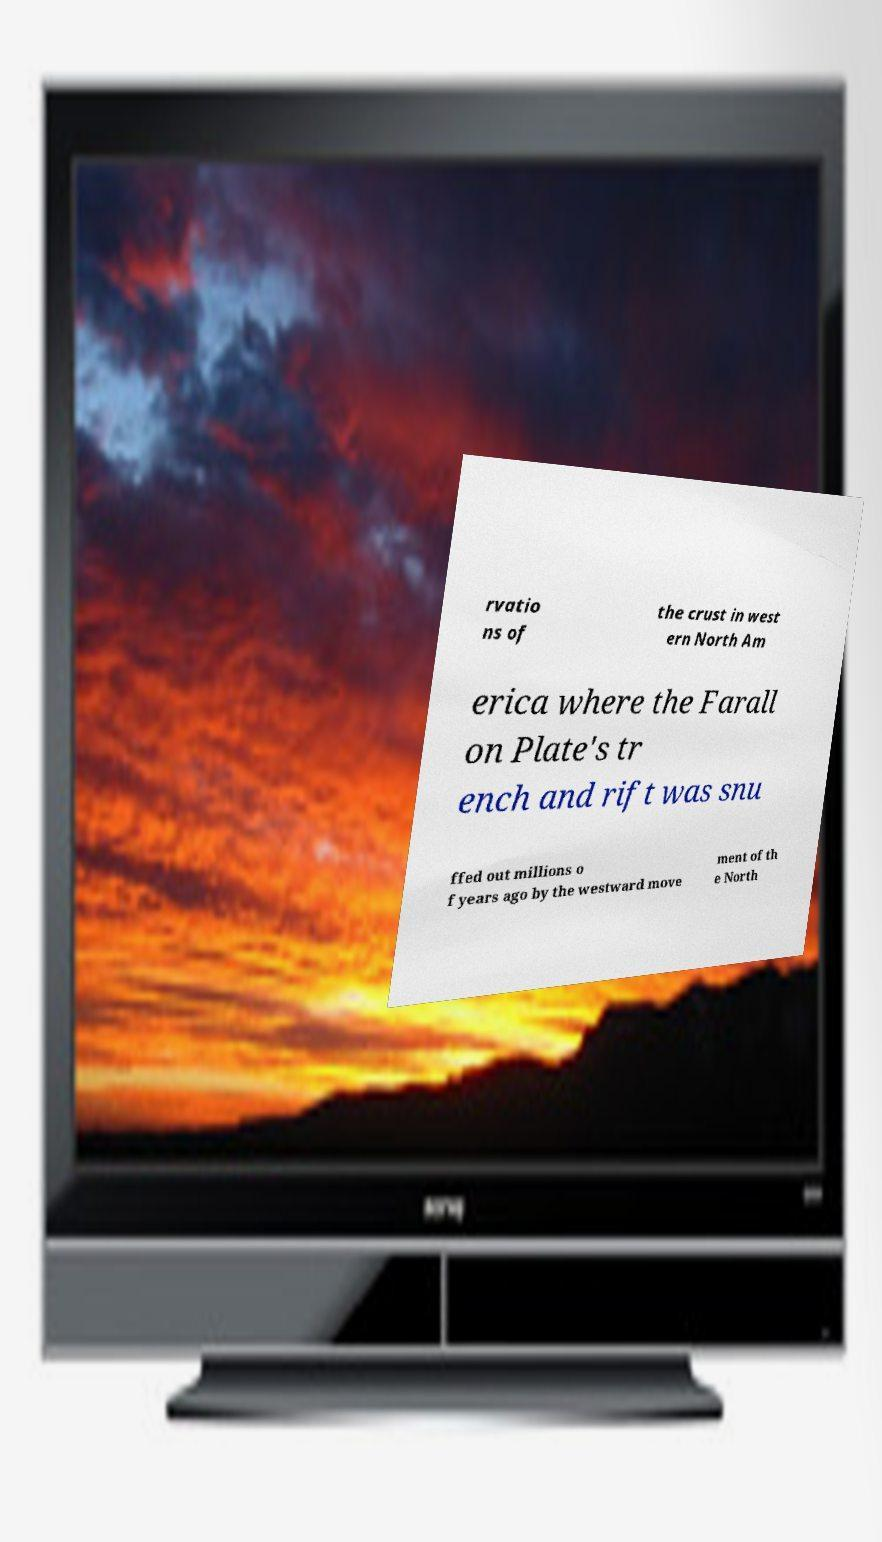Please identify and transcribe the text found in this image. rvatio ns of the crust in west ern North Am erica where the Farall on Plate's tr ench and rift was snu ffed out millions o f years ago by the westward move ment of th e North 